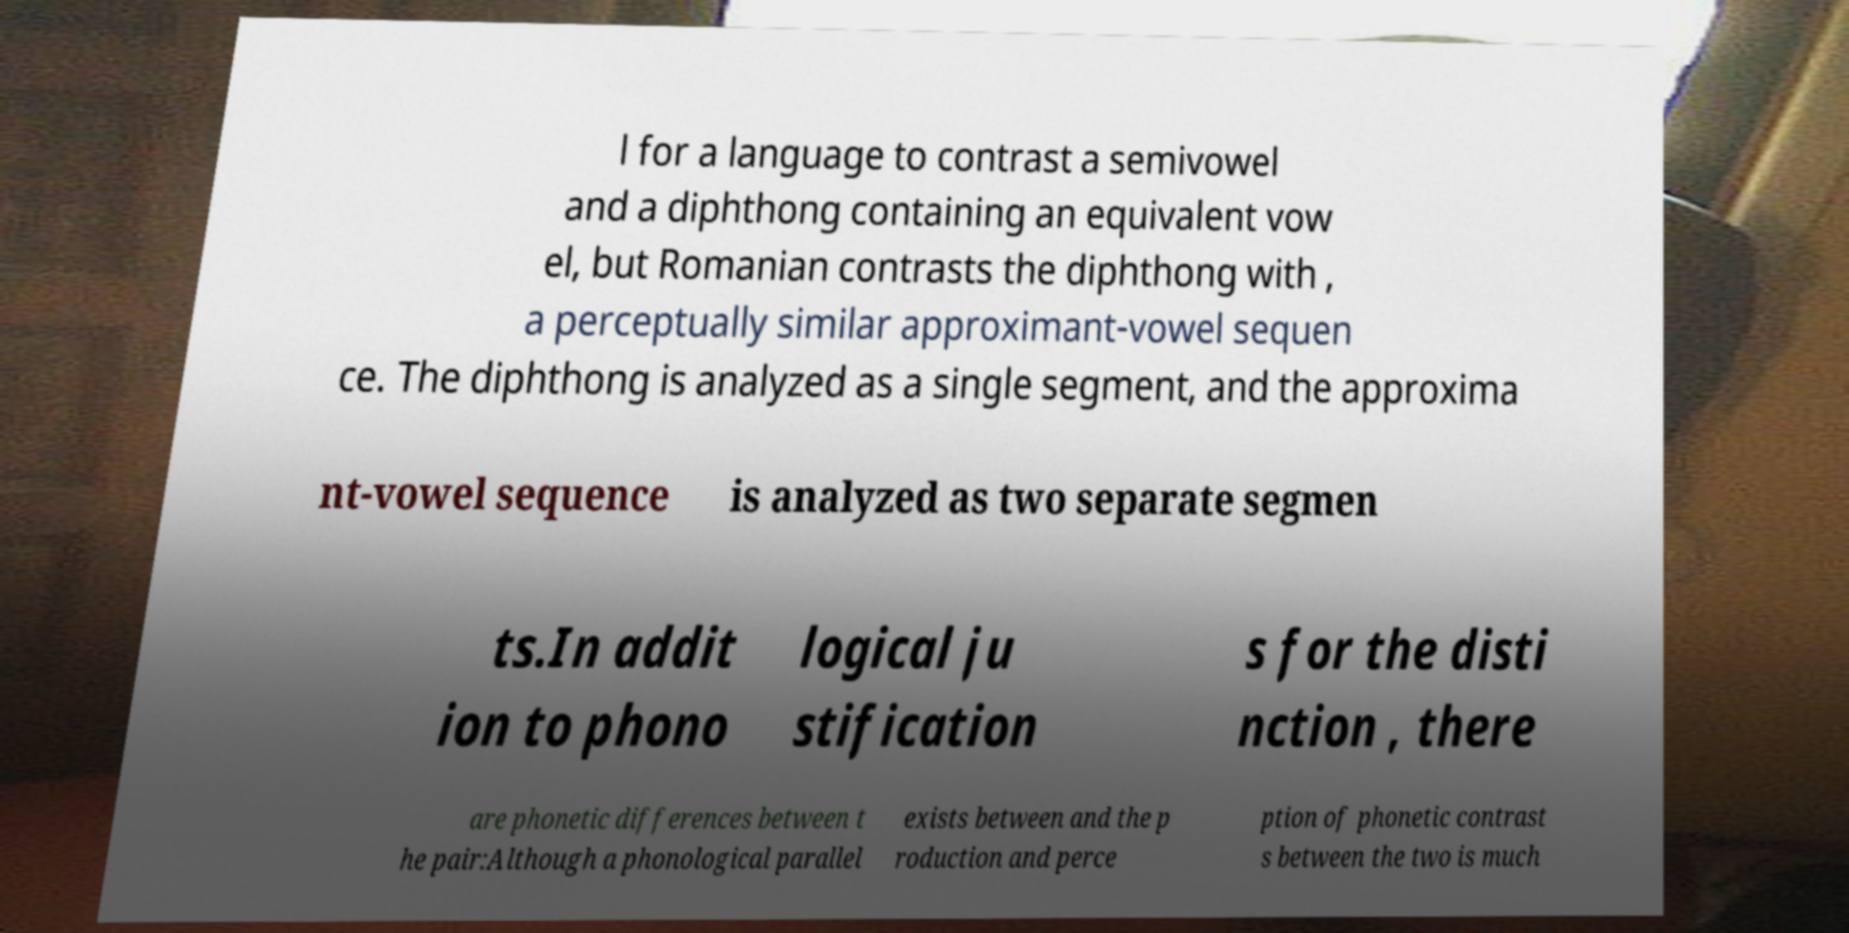For documentation purposes, I need the text within this image transcribed. Could you provide that? l for a language to contrast a semivowel and a diphthong containing an equivalent vow el, but Romanian contrasts the diphthong with , a perceptually similar approximant-vowel sequen ce. The diphthong is analyzed as a single segment, and the approxima nt-vowel sequence is analyzed as two separate segmen ts.In addit ion to phono logical ju stification s for the disti nction , there are phonetic differences between t he pair:Although a phonological parallel exists between and the p roduction and perce ption of phonetic contrast s between the two is much 